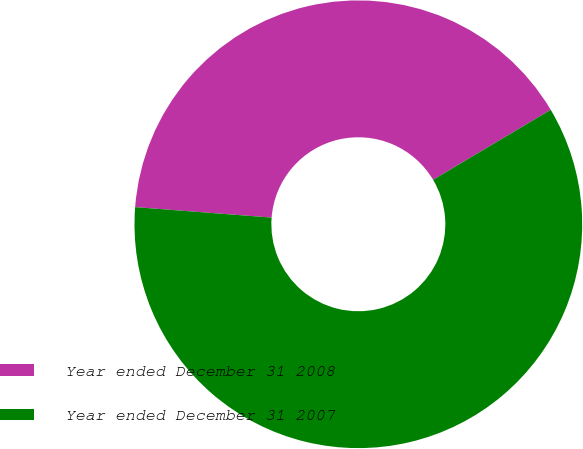Convert chart. <chart><loc_0><loc_0><loc_500><loc_500><pie_chart><fcel>Year ended December 31 2008<fcel>Year ended December 31 2007<nl><fcel>40.24%<fcel>59.76%<nl></chart> 